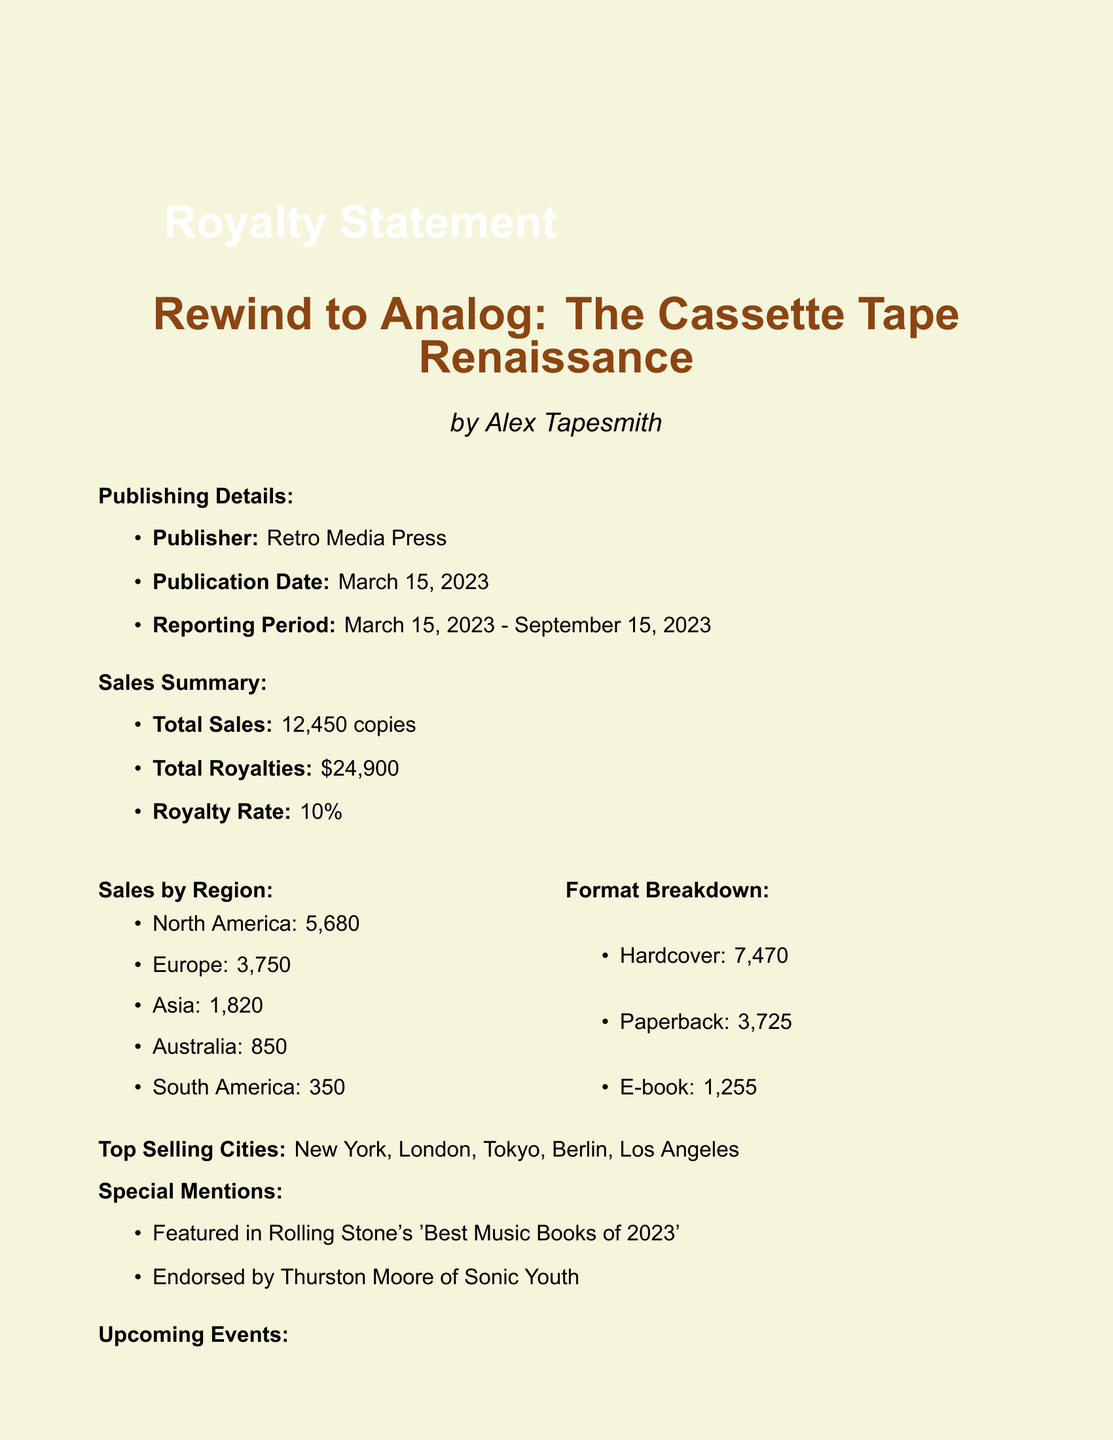what is the book title? The book title is mentioned prominently at the beginning of the document.
Answer: Rewind to Analog: The Cassette Tape Renaissance who is the author? The author is listed right below the book title in the document.
Answer: Alex Tapesmith what is the total sales figure? Total sales are provided in the sales summary section.
Answer: 12,450 copies how much are the total royalties? The total royalties amount is specified in the sales summary section.
Answer: $24,900 what is the royalty rate? The royalty rate is included in the sales summary.
Answer: 10% which region had the highest sales? The sales by region section details sales figures for each region.
Answer: North America what is the top selling city? The top selling cities are listed in the document.
Answer: New York how many hardcover copies were sold? The format breakdown section shows the number of hardcover sales.
Answer: 7,470 what are the upcoming events? The document lists upcoming events related to the book.
Answer: Book signing at Rough Trade NYC, October 12, 2023 which publication featured the book? Special mentions include media coverage of the book.
Answer: Rolling Stone's 'Best Music Books of 2023' 